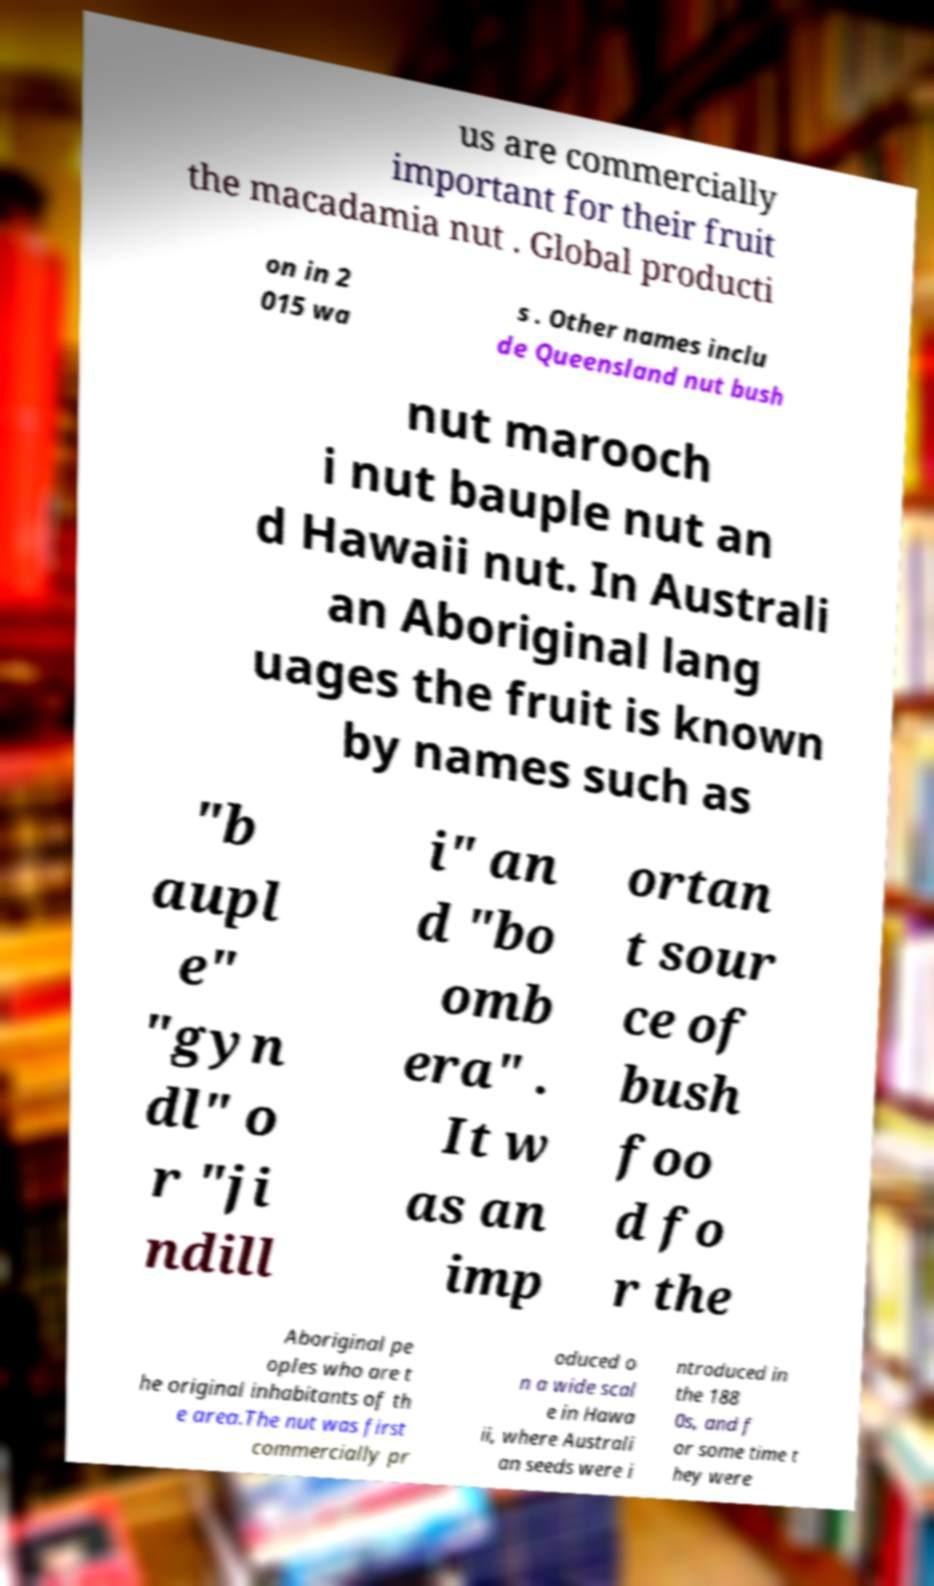Can you read and provide the text displayed in the image?This photo seems to have some interesting text. Can you extract and type it out for me? us are commercially important for their fruit the macadamia nut . Global producti on in 2 015 wa s . Other names inclu de Queensland nut bush nut marooch i nut bauple nut an d Hawaii nut. In Australi an Aboriginal lang uages the fruit is known by names such as "b aupl e" "gyn dl" o r "ji ndill i" an d "bo omb era" . It w as an imp ortan t sour ce of bush foo d fo r the Aboriginal pe oples who are t he original inhabitants of th e area.The nut was first commercially pr oduced o n a wide scal e in Hawa ii, where Australi an seeds were i ntroduced in the 188 0s, and f or some time t hey were 